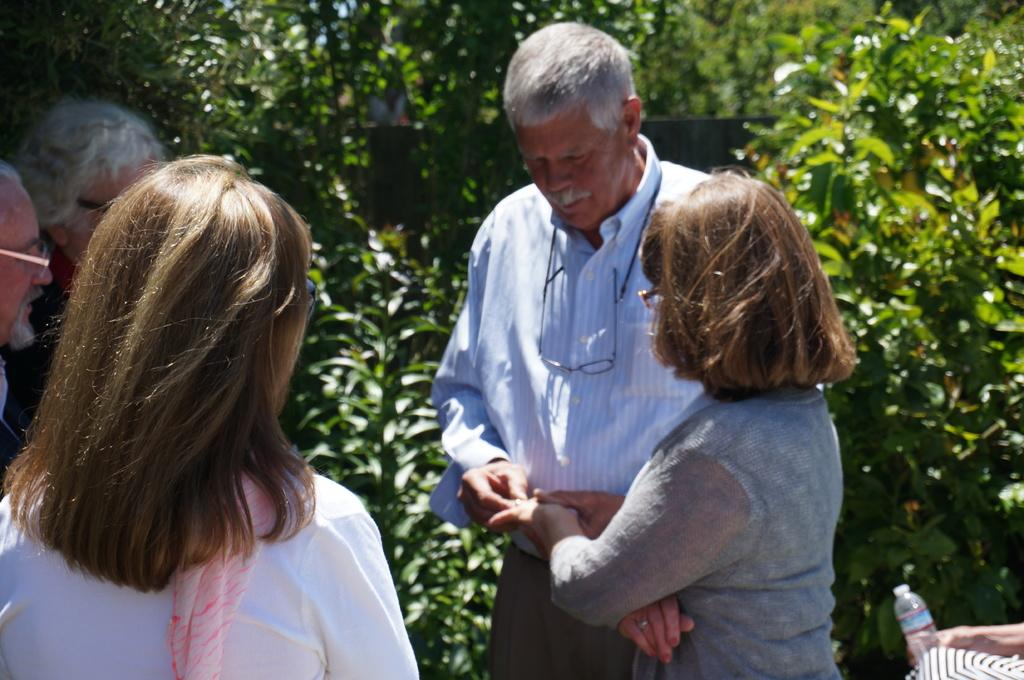What can be seen in the image? There are people standing in the image. What is visible in the background of the image? There are trees in the background of the image. What type of collar can be seen on the church in the image? There is no church present in the image, so there is no collar to observe. 